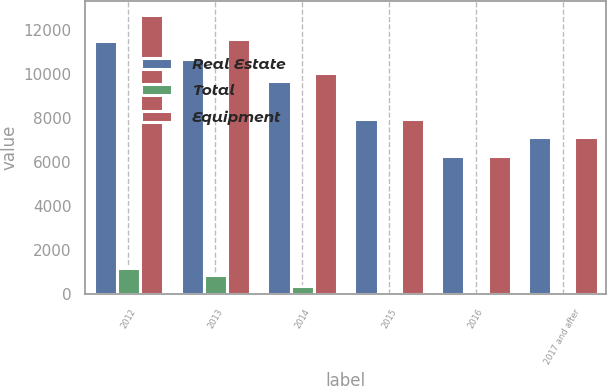Convert chart. <chart><loc_0><loc_0><loc_500><loc_500><stacked_bar_chart><ecel><fcel>2012<fcel>2013<fcel>2014<fcel>2015<fcel>2016<fcel>2017 and after<nl><fcel>Real Estate<fcel>11469<fcel>10668<fcel>9660<fcel>7936<fcel>6289<fcel>7114<nl><fcel>Total<fcel>1186<fcel>895<fcel>386<fcel>31<fcel>3<fcel>0<nl><fcel>Equipment<fcel>12655<fcel>11563<fcel>10046<fcel>7967<fcel>6292<fcel>7114<nl></chart> 